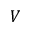<formula> <loc_0><loc_0><loc_500><loc_500>V</formula> 